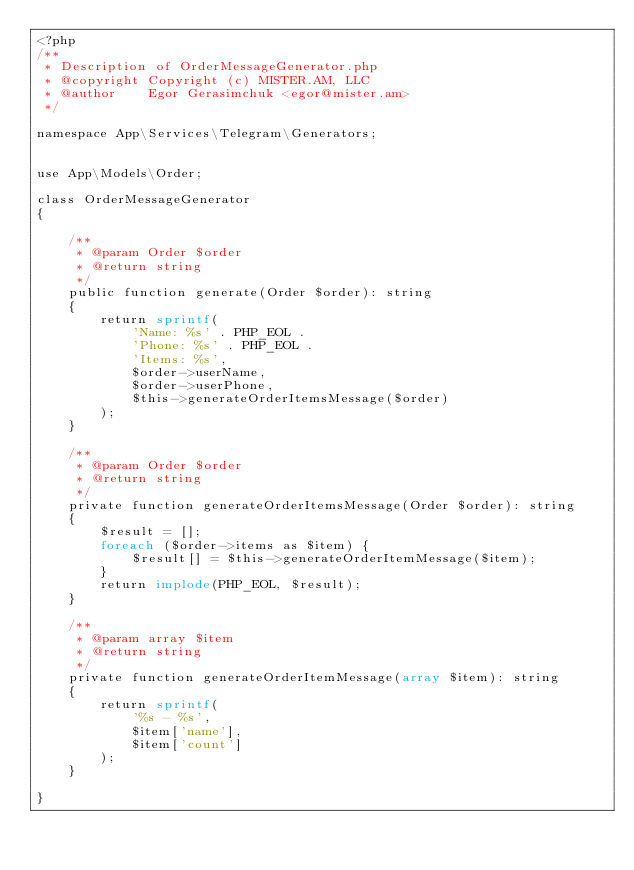Convert code to text. <code><loc_0><loc_0><loc_500><loc_500><_PHP_><?php
/**
 * Description of OrderMessageGenerator.php
 * @copyright Copyright (c) MISTER.AM, LLC
 * @author    Egor Gerasimchuk <egor@mister.am>
 */

namespace App\Services\Telegram\Generators;


use App\Models\Order;

class OrderMessageGenerator
{

    /**
     * @param Order $order
     * @return string
     */
    public function generate(Order $order): string
    {
        return sprintf(
            'Name: %s' . PHP_EOL .
            'Phone: %s' . PHP_EOL .
            'Items: %s',
            $order->userName,
            $order->userPhone,
            $this->generateOrderItemsMessage($order)
        );
    }

    /**
     * @param Order $order
     * @return string
     */
    private function generateOrderItemsMessage(Order $order): string
    {
        $result = [];
        foreach ($order->items as $item) {
            $result[] = $this->generateOrderItemMessage($item);
        }
        return implode(PHP_EOL, $result);
    }

    /**
     * @param array $item
     * @return string
     */
    private function generateOrderItemMessage(array $item): string
    {
        return sprintf(
            '%s - %s',
            $item['name'],
            $item['count']
        );
    }

}
</code> 